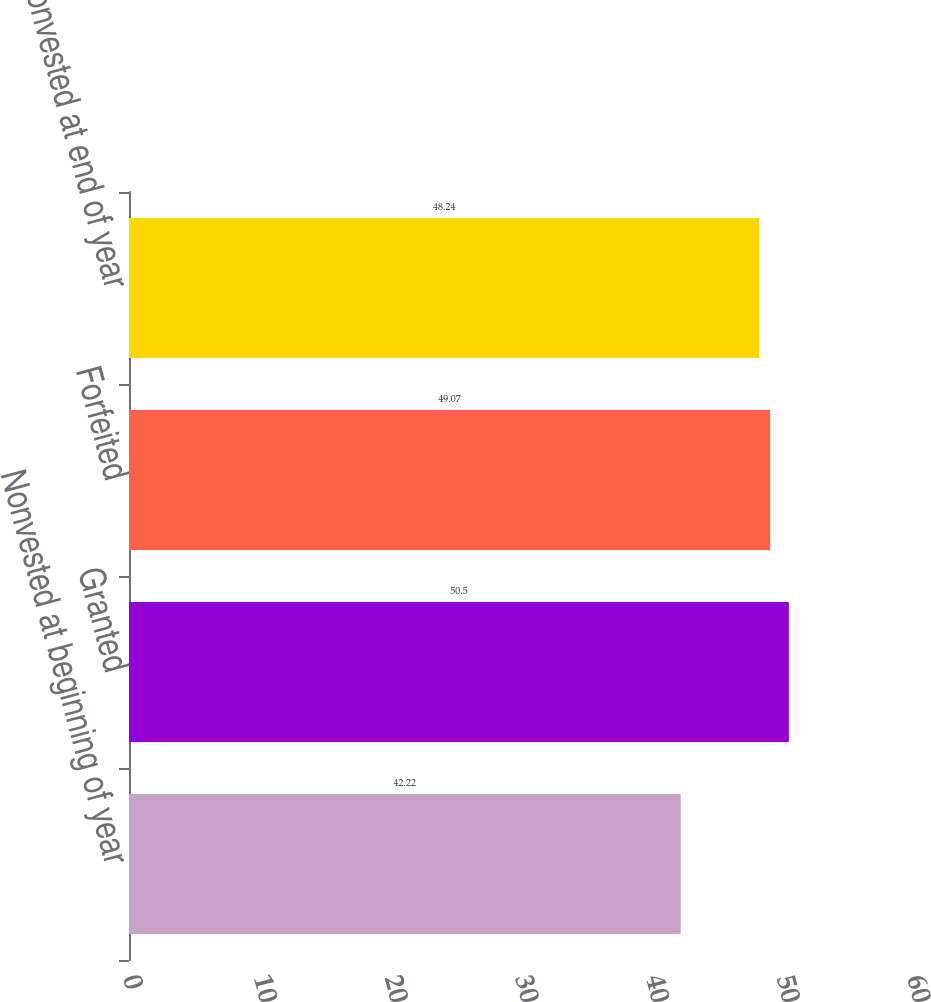<chart> <loc_0><loc_0><loc_500><loc_500><bar_chart><fcel>Nonvested at beginning of year<fcel>Granted<fcel>Forfeited<fcel>Nonvested at end of year<nl><fcel>42.22<fcel>50.5<fcel>49.07<fcel>48.24<nl></chart> 